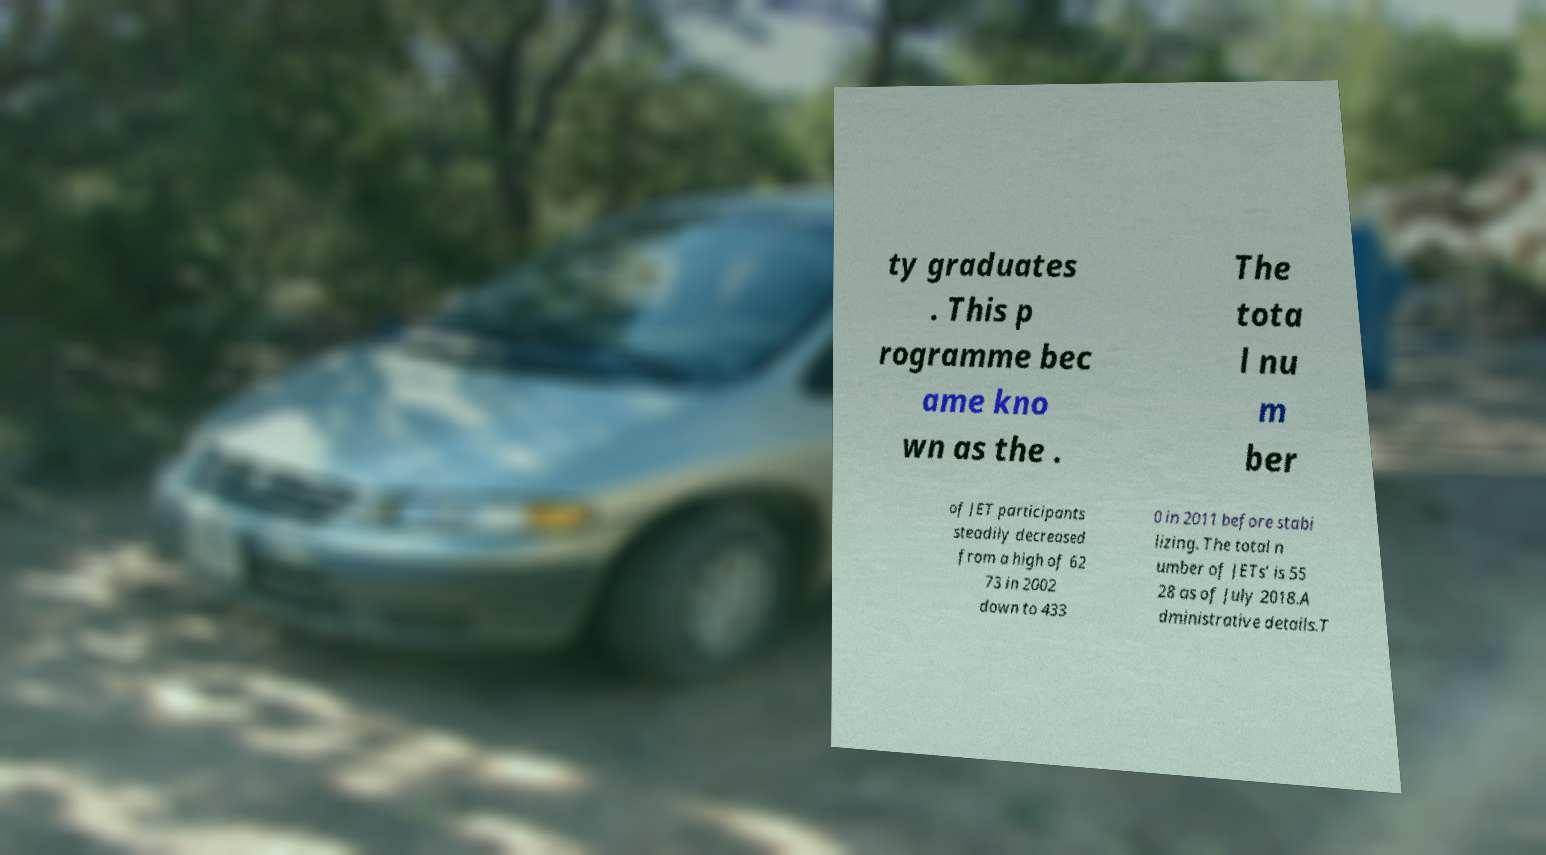What messages or text are displayed in this image? I need them in a readable, typed format. ty graduates . This p rogramme bec ame kno wn as the . The tota l nu m ber of JET participants steadily decreased from a high of 62 73 in 2002 down to 433 0 in 2011 before stabi lizing. The total n umber of JETs' is 55 28 as of July 2018.A dministrative details.T 